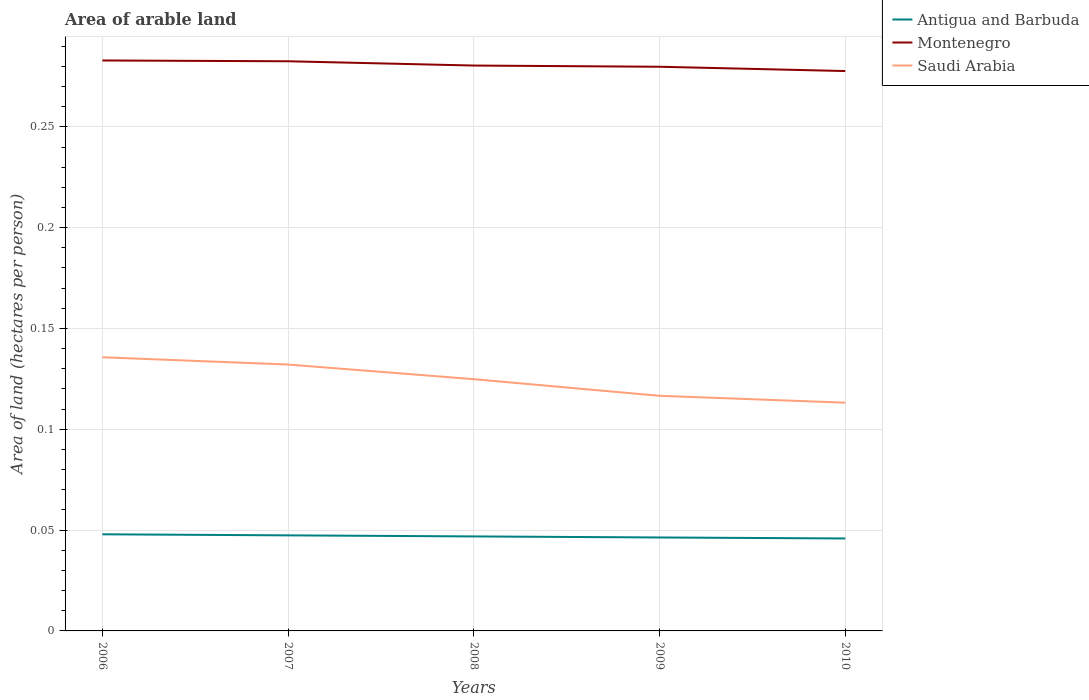Across all years, what is the maximum total arable land in Antigua and Barbuda?
Ensure brevity in your answer.  0.05. What is the total total arable land in Saudi Arabia in the graph?
Keep it short and to the point. 0.02. What is the difference between the highest and the second highest total arable land in Montenegro?
Keep it short and to the point. 0.01. What is the difference between the highest and the lowest total arable land in Antigua and Barbuda?
Keep it short and to the point. 2. Is the total arable land in Montenegro strictly greater than the total arable land in Saudi Arabia over the years?
Your answer should be very brief. No. How many lines are there?
Offer a very short reply. 3. How many years are there in the graph?
Offer a very short reply. 5. What is the difference between two consecutive major ticks on the Y-axis?
Offer a terse response. 0.05. Does the graph contain grids?
Provide a succinct answer. Yes. Where does the legend appear in the graph?
Offer a terse response. Top right. How many legend labels are there?
Keep it short and to the point. 3. What is the title of the graph?
Offer a terse response. Area of arable land. Does "China" appear as one of the legend labels in the graph?
Give a very brief answer. No. What is the label or title of the Y-axis?
Your answer should be compact. Area of land (hectares per person). What is the Area of land (hectares per person) of Antigua and Barbuda in 2006?
Provide a succinct answer. 0.05. What is the Area of land (hectares per person) of Montenegro in 2006?
Make the answer very short. 0.28. What is the Area of land (hectares per person) of Saudi Arabia in 2006?
Ensure brevity in your answer.  0.14. What is the Area of land (hectares per person) of Antigua and Barbuda in 2007?
Offer a very short reply. 0.05. What is the Area of land (hectares per person) of Montenegro in 2007?
Offer a very short reply. 0.28. What is the Area of land (hectares per person) in Saudi Arabia in 2007?
Your response must be concise. 0.13. What is the Area of land (hectares per person) in Antigua and Barbuda in 2008?
Offer a terse response. 0.05. What is the Area of land (hectares per person) in Montenegro in 2008?
Keep it short and to the point. 0.28. What is the Area of land (hectares per person) in Saudi Arabia in 2008?
Your answer should be compact. 0.12. What is the Area of land (hectares per person) of Antigua and Barbuda in 2009?
Provide a short and direct response. 0.05. What is the Area of land (hectares per person) in Montenegro in 2009?
Provide a short and direct response. 0.28. What is the Area of land (hectares per person) of Saudi Arabia in 2009?
Offer a terse response. 0.12. What is the Area of land (hectares per person) in Antigua and Barbuda in 2010?
Ensure brevity in your answer.  0.05. What is the Area of land (hectares per person) of Montenegro in 2010?
Provide a short and direct response. 0.28. What is the Area of land (hectares per person) in Saudi Arabia in 2010?
Your answer should be very brief. 0.11. Across all years, what is the maximum Area of land (hectares per person) in Antigua and Barbuda?
Ensure brevity in your answer.  0.05. Across all years, what is the maximum Area of land (hectares per person) in Montenegro?
Your response must be concise. 0.28. Across all years, what is the maximum Area of land (hectares per person) in Saudi Arabia?
Provide a succinct answer. 0.14. Across all years, what is the minimum Area of land (hectares per person) of Antigua and Barbuda?
Ensure brevity in your answer.  0.05. Across all years, what is the minimum Area of land (hectares per person) in Montenegro?
Give a very brief answer. 0.28. Across all years, what is the minimum Area of land (hectares per person) in Saudi Arabia?
Provide a short and direct response. 0.11. What is the total Area of land (hectares per person) of Antigua and Barbuda in the graph?
Offer a terse response. 0.23. What is the total Area of land (hectares per person) in Montenegro in the graph?
Make the answer very short. 1.4. What is the total Area of land (hectares per person) of Saudi Arabia in the graph?
Make the answer very short. 0.62. What is the difference between the Area of land (hectares per person) in Montenegro in 2006 and that in 2007?
Your response must be concise. 0. What is the difference between the Area of land (hectares per person) of Saudi Arabia in 2006 and that in 2007?
Provide a succinct answer. 0. What is the difference between the Area of land (hectares per person) of Antigua and Barbuda in 2006 and that in 2008?
Your answer should be compact. 0. What is the difference between the Area of land (hectares per person) in Montenegro in 2006 and that in 2008?
Offer a terse response. 0. What is the difference between the Area of land (hectares per person) in Saudi Arabia in 2006 and that in 2008?
Keep it short and to the point. 0.01. What is the difference between the Area of land (hectares per person) in Antigua and Barbuda in 2006 and that in 2009?
Your response must be concise. 0. What is the difference between the Area of land (hectares per person) in Montenegro in 2006 and that in 2009?
Provide a short and direct response. 0. What is the difference between the Area of land (hectares per person) in Saudi Arabia in 2006 and that in 2009?
Provide a short and direct response. 0.02. What is the difference between the Area of land (hectares per person) of Antigua and Barbuda in 2006 and that in 2010?
Ensure brevity in your answer.  0. What is the difference between the Area of land (hectares per person) in Montenegro in 2006 and that in 2010?
Your answer should be compact. 0.01. What is the difference between the Area of land (hectares per person) in Saudi Arabia in 2006 and that in 2010?
Provide a succinct answer. 0.02. What is the difference between the Area of land (hectares per person) of Antigua and Barbuda in 2007 and that in 2008?
Offer a terse response. 0. What is the difference between the Area of land (hectares per person) in Montenegro in 2007 and that in 2008?
Offer a very short reply. 0. What is the difference between the Area of land (hectares per person) in Saudi Arabia in 2007 and that in 2008?
Your answer should be very brief. 0.01. What is the difference between the Area of land (hectares per person) of Montenegro in 2007 and that in 2009?
Your answer should be very brief. 0. What is the difference between the Area of land (hectares per person) of Saudi Arabia in 2007 and that in 2009?
Your answer should be very brief. 0.02. What is the difference between the Area of land (hectares per person) in Antigua and Barbuda in 2007 and that in 2010?
Keep it short and to the point. 0. What is the difference between the Area of land (hectares per person) in Montenegro in 2007 and that in 2010?
Provide a short and direct response. 0. What is the difference between the Area of land (hectares per person) in Saudi Arabia in 2007 and that in 2010?
Ensure brevity in your answer.  0.02. What is the difference between the Area of land (hectares per person) of Montenegro in 2008 and that in 2009?
Keep it short and to the point. 0. What is the difference between the Area of land (hectares per person) of Saudi Arabia in 2008 and that in 2009?
Provide a succinct answer. 0.01. What is the difference between the Area of land (hectares per person) in Montenegro in 2008 and that in 2010?
Make the answer very short. 0. What is the difference between the Area of land (hectares per person) of Saudi Arabia in 2008 and that in 2010?
Offer a very short reply. 0.01. What is the difference between the Area of land (hectares per person) of Antigua and Barbuda in 2009 and that in 2010?
Keep it short and to the point. 0. What is the difference between the Area of land (hectares per person) in Montenegro in 2009 and that in 2010?
Ensure brevity in your answer.  0. What is the difference between the Area of land (hectares per person) in Saudi Arabia in 2009 and that in 2010?
Keep it short and to the point. 0. What is the difference between the Area of land (hectares per person) of Antigua and Barbuda in 2006 and the Area of land (hectares per person) of Montenegro in 2007?
Give a very brief answer. -0.23. What is the difference between the Area of land (hectares per person) in Antigua and Barbuda in 2006 and the Area of land (hectares per person) in Saudi Arabia in 2007?
Make the answer very short. -0.08. What is the difference between the Area of land (hectares per person) in Montenegro in 2006 and the Area of land (hectares per person) in Saudi Arabia in 2007?
Provide a short and direct response. 0.15. What is the difference between the Area of land (hectares per person) of Antigua and Barbuda in 2006 and the Area of land (hectares per person) of Montenegro in 2008?
Offer a very short reply. -0.23. What is the difference between the Area of land (hectares per person) in Antigua and Barbuda in 2006 and the Area of land (hectares per person) in Saudi Arabia in 2008?
Give a very brief answer. -0.08. What is the difference between the Area of land (hectares per person) in Montenegro in 2006 and the Area of land (hectares per person) in Saudi Arabia in 2008?
Your answer should be very brief. 0.16. What is the difference between the Area of land (hectares per person) of Antigua and Barbuda in 2006 and the Area of land (hectares per person) of Montenegro in 2009?
Ensure brevity in your answer.  -0.23. What is the difference between the Area of land (hectares per person) of Antigua and Barbuda in 2006 and the Area of land (hectares per person) of Saudi Arabia in 2009?
Your response must be concise. -0.07. What is the difference between the Area of land (hectares per person) of Montenegro in 2006 and the Area of land (hectares per person) of Saudi Arabia in 2009?
Offer a very short reply. 0.17. What is the difference between the Area of land (hectares per person) in Antigua and Barbuda in 2006 and the Area of land (hectares per person) in Montenegro in 2010?
Provide a short and direct response. -0.23. What is the difference between the Area of land (hectares per person) of Antigua and Barbuda in 2006 and the Area of land (hectares per person) of Saudi Arabia in 2010?
Give a very brief answer. -0.07. What is the difference between the Area of land (hectares per person) of Montenegro in 2006 and the Area of land (hectares per person) of Saudi Arabia in 2010?
Your response must be concise. 0.17. What is the difference between the Area of land (hectares per person) in Antigua and Barbuda in 2007 and the Area of land (hectares per person) in Montenegro in 2008?
Offer a terse response. -0.23. What is the difference between the Area of land (hectares per person) of Antigua and Barbuda in 2007 and the Area of land (hectares per person) of Saudi Arabia in 2008?
Provide a succinct answer. -0.08. What is the difference between the Area of land (hectares per person) of Montenegro in 2007 and the Area of land (hectares per person) of Saudi Arabia in 2008?
Make the answer very short. 0.16. What is the difference between the Area of land (hectares per person) in Antigua and Barbuda in 2007 and the Area of land (hectares per person) in Montenegro in 2009?
Your answer should be compact. -0.23. What is the difference between the Area of land (hectares per person) in Antigua and Barbuda in 2007 and the Area of land (hectares per person) in Saudi Arabia in 2009?
Keep it short and to the point. -0.07. What is the difference between the Area of land (hectares per person) in Montenegro in 2007 and the Area of land (hectares per person) in Saudi Arabia in 2009?
Provide a succinct answer. 0.17. What is the difference between the Area of land (hectares per person) of Antigua and Barbuda in 2007 and the Area of land (hectares per person) of Montenegro in 2010?
Provide a short and direct response. -0.23. What is the difference between the Area of land (hectares per person) of Antigua and Barbuda in 2007 and the Area of land (hectares per person) of Saudi Arabia in 2010?
Your response must be concise. -0.07. What is the difference between the Area of land (hectares per person) in Montenegro in 2007 and the Area of land (hectares per person) in Saudi Arabia in 2010?
Your response must be concise. 0.17. What is the difference between the Area of land (hectares per person) in Antigua and Barbuda in 2008 and the Area of land (hectares per person) in Montenegro in 2009?
Provide a short and direct response. -0.23. What is the difference between the Area of land (hectares per person) of Antigua and Barbuda in 2008 and the Area of land (hectares per person) of Saudi Arabia in 2009?
Offer a terse response. -0.07. What is the difference between the Area of land (hectares per person) of Montenegro in 2008 and the Area of land (hectares per person) of Saudi Arabia in 2009?
Keep it short and to the point. 0.16. What is the difference between the Area of land (hectares per person) of Antigua and Barbuda in 2008 and the Area of land (hectares per person) of Montenegro in 2010?
Provide a short and direct response. -0.23. What is the difference between the Area of land (hectares per person) of Antigua and Barbuda in 2008 and the Area of land (hectares per person) of Saudi Arabia in 2010?
Your answer should be very brief. -0.07. What is the difference between the Area of land (hectares per person) of Montenegro in 2008 and the Area of land (hectares per person) of Saudi Arabia in 2010?
Offer a terse response. 0.17. What is the difference between the Area of land (hectares per person) of Antigua and Barbuda in 2009 and the Area of land (hectares per person) of Montenegro in 2010?
Make the answer very short. -0.23. What is the difference between the Area of land (hectares per person) in Antigua and Barbuda in 2009 and the Area of land (hectares per person) in Saudi Arabia in 2010?
Give a very brief answer. -0.07. What is the difference between the Area of land (hectares per person) in Montenegro in 2009 and the Area of land (hectares per person) in Saudi Arabia in 2010?
Give a very brief answer. 0.17. What is the average Area of land (hectares per person) of Antigua and Barbuda per year?
Your answer should be compact. 0.05. What is the average Area of land (hectares per person) of Montenegro per year?
Your answer should be very brief. 0.28. What is the average Area of land (hectares per person) of Saudi Arabia per year?
Provide a short and direct response. 0.12. In the year 2006, what is the difference between the Area of land (hectares per person) in Antigua and Barbuda and Area of land (hectares per person) in Montenegro?
Your response must be concise. -0.23. In the year 2006, what is the difference between the Area of land (hectares per person) in Antigua and Barbuda and Area of land (hectares per person) in Saudi Arabia?
Make the answer very short. -0.09. In the year 2006, what is the difference between the Area of land (hectares per person) in Montenegro and Area of land (hectares per person) in Saudi Arabia?
Provide a succinct answer. 0.15. In the year 2007, what is the difference between the Area of land (hectares per person) in Antigua and Barbuda and Area of land (hectares per person) in Montenegro?
Provide a succinct answer. -0.24. In the year 2007, what is the difference between the Area of land (hectares per person) of Antigua and Barbuda and Area of land (hectares per person) of Saudi Arabia?
Offer a terse response. -0.08. In the year 2007, what is the difference between the Area of land (hectares per person) in Montenegro and Area of land (hectares per person) in Saudi Arabia?
Your answer should be very brief. 0.15. In the year 2008, what is the difference between the Area of land (hectares per person) of Antigua and Barbuda and Area of land (hectares per person) of Montenegro?
Make the answer very short. -0.23. In the year 2008, what is the difference between the Area of land (hectares per person) in Antigua and Barbuda and Area of land (hectares per person) in Saudi Arabia?
Offer a terse response. -0.08. In the year 2008, what is the difference between the Area of land (hectares per person) of Montenegro and Area of land (hectares per person) of Saudi Arabia?
Ensure brevity in your answer.  0.16. In the year 2009, what is the difference between the Area of land (hectares per person) of Antigua and Barbuda and Area of land (hectares per person) of Montenegro?
Offer a terse response. -0.23. In the year 2009, what is the difference between the Area of land (hectares per person) in Antigua and Barbuda and Area of land (hectares per person) in Saudi Arabia?
Make the answer very short. -0.07. In the year 2009, what is the difference between the Area of land (hectares per person) of Montenegro and Area of land (hectares per person) of Saudi Arabia?
Ensure brevity in your answer.  0.16. In the year 2010, what is the difference between the Area of land (hectares per person) of Antigua and Barbuda and Area of land (hectares per person) of Montenegro?
Offer a terse response. -0.23. In the year 2010, what is the difference between the Area of land (hectares per person) in Antigua and Barbuda and Area of land (hectares per person) in Saudi Arabia?
Offer a very short reply. -0.07. In the year 2010, what is the difference between the Area of land (hectares per person) in Montenegro and Area of land (hectares per person) in Saudi Arabia?
Offer a terse response. 0.16. What is the ratio of the Area of land (hectares per person) in Antigua and Barbuda in 2006 to that in 2007?
Your response must be concise. 1.01. What is the ratio of the Area of land (hectares per person) in Montenegro in 2006 to that in 2007?
Ensure brevity in your answer.  1. What is the ratio of the Area of land (hectares per person) of Saudi Arabia in 2006 to that in 2007?
Provide a succinct answer. 1.03. What is the ratio of the Area of land (hectares per person) of Antigua and Barbuda in 2006 to that in 2008?
Give a very brief answer. 1.02. What is the ratio of the Area of land (hectares per person) in Montenegro in 2006 to that in 2008?
Give a very brief answer. 1.01. What is the ratio of the Area of land (hectares per person) of Saudi Arabia in 2006 to that in 2008?
Your answer should be compact. 1.09. What is the ratio of the Area of land (hectares per person) of Antigua and Barbuda in 2006 to that in 2009?
Ensure brevity in your answer.  1.03. What is the ratio of the Area of land (hectares per person) in Montenegro in 2006 to that in 2009?
Provide a succinct answer. 1.01. What is the ratio of the Area of land (hectares per person) in Saudi Arabia in 2006 to that in 2009?
Provide a short and direct response. 1.16. What is the ratio of the Area of land (hectares per person) of Antigua and Barbuda in 2006 to that in 2010?
Provide a short and direct response. 1.05. What is the ratio of the Area of land (hectares per person) in Montenegro in 2006 to that in 2010?
Ensure brevity in your answer.  1.02. What is the ratio of the Area of land (hectares per person) of Saudi Arabia in 2006 to that in 2010?
Provide a succinct answer. 1.2. What is the ratio of the Area of land (hectares per person) of Antigua and Barbuda in 2007 to that in 2008?
Make the answer very short. 1.01. What is the ratio of the Area of land (hectares per person) of Montenegro in 2007 to that in 2008?
Make the answer very short. 1.01. What is the ratio of the Area of land (hectares per person) in Saudi Arabia in 2007 to that in 2008?
Your response must be concise. 1.06. What is the ratio of the Area of land (hectares per person) in Antigua and Barbuda in 2007 to that in 2009?
Offer a terse response. 1.02. What is the ratio of the Area of land (hectares per person) of Montenegro in 2007 to that in 2009?
Make the answer very short. 1.01. What is the ratio of the Area of land (hectares per person) of Saudi Arabia in 2007 to that in 2009?
Your response must be concise. 1.13. What is the ratio of the Area of land (hectares per person) in Antigua and Barbuda in 2007 to that in 2010?
Offer a terse response. 1.03. What is the ratio of the Area of land (hectares per person) in Montenegro in 2007 to that in 2010?
Offer a very short reply. 1.02. What is the ratio of the Area of land (hectares per person) of Saudi Arabia in 2007 to that in 2010?
Provide a succinct answer. 1.17. What is the ratio of the Area of land (hectares per person) of Antigua and Barbuda in 2008 to that in 2009?
Give a very brief answer. 1.01. What is the ratio of the Area of land (hectares per person) of Montenegro in 2008 to that in 2009?
Your response must be concise. 1. What is the ratio of the Area of land (hectares per person) in Saudi Arabia in 2008 to that in 2009?
Provide a short and direct response. 1.07. What is the ratio of the Area of land (hectares per person) of Antigua and Barbuda in 2008 to that in 2010?
Provide a short and direct response. 1.02. What is the ratio of the Area of land (hectares per person) of Montenegro in 2008 to that in 2010?
Provide a succinct answer. 1.01. What is the ratio of the Area of land (hectares per person) in Saudi Arabia in 2008 to that in 2010?
Ensure brevity in your answer.  1.1. What is the ratio of the Area of land (hectares per person) in Antigua and Barbuda in 2009 to that in 2010?
Ensure brevity in your answer.  1.01. What is the ratio of the Area of land (hectares per person) of Montenegro in 2009 to that in 2010?
Provide a short and direct response. 1.01. What is the difference between the highest and the second highest Area of land (hectares per person) of Montenegro?
Your answer should be very brief. 0. What is the difference between the highest and the second highest Area of land (hectares per person) in Saudi Arabia?
Provide a short and direct response. 0. What is the difference between the highest and the lowest Area of land (hectares per person) in Antigua and Barbuda?
Offer a terse response. 0. What is the difference between the highest and the lowest Area of land (hectares per person) of Montenegro?
Provide a short and direct response. 0.01. What is the difference between the highest and the lowest Area of land (hectares per person) in Saudi Arabia?
Provide a succinct answer. 0.02. 